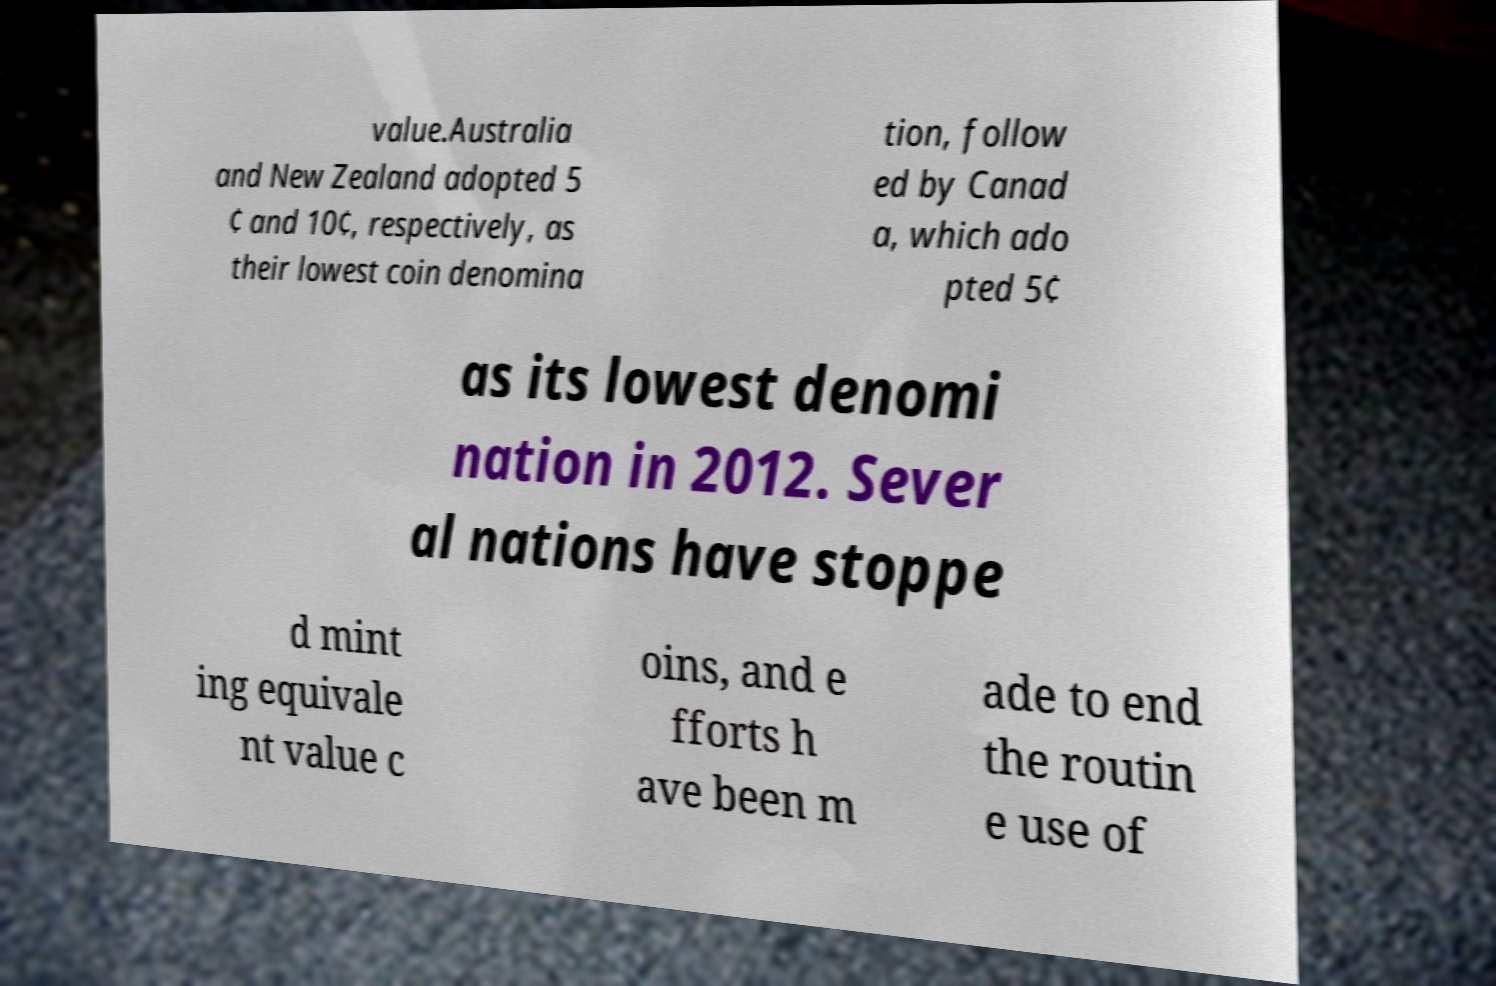There's text embedded in this image that I need extracted. Can you transcribe it verbatim? value.Australia and New Zealand adopted 5 ¢ and 10¢, respectively, as their lowest coin denomina tion, follow ed by Canad a, which ado pted 5¢ as its lowest denomi nation in 2012. Sever al nations have stoppe d mint ing equivale nt value c oins, and e fforts h ave been m ade to end the routin e use of 